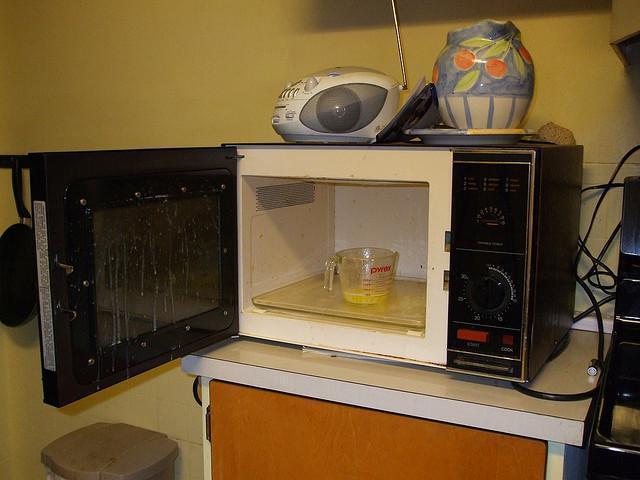How is the measuring cup being heated?
Choose the correct response and explain in the format: 'Answer: answer
Rationale: rationale.'
Options: Grill, microwave, oven, stove. Answer: microwave.
Rationale: They put it in the microwave to be heated. 